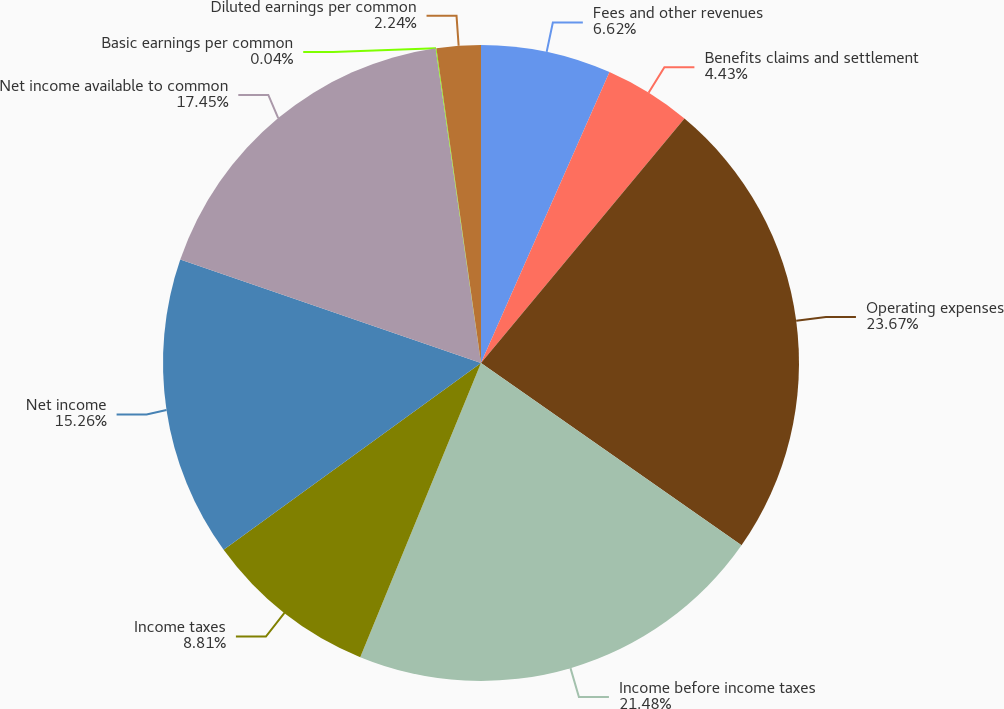Convert chart. <chart><loc_0><loc_0><loc_500><loc_500><pie_chart><fcel>Fees and other revenues<fcel>Benefits claims and settlement<fcel>Operating expenses<fcel>Income before income taxes<fcel>Income taxes<fcel>Net income<fcel>Net income available to common<fcel>Basic earnings per common<fcel>Diluted earnings per common<nl><fcel>6.62%<fcel>4.43%<fcel>23.67%<fcel>21.48%<fcel>8.81%<fcel>15.26%<fcel>17.45%<fcel>0.04%<fcel>2.24%<nl></chart> 